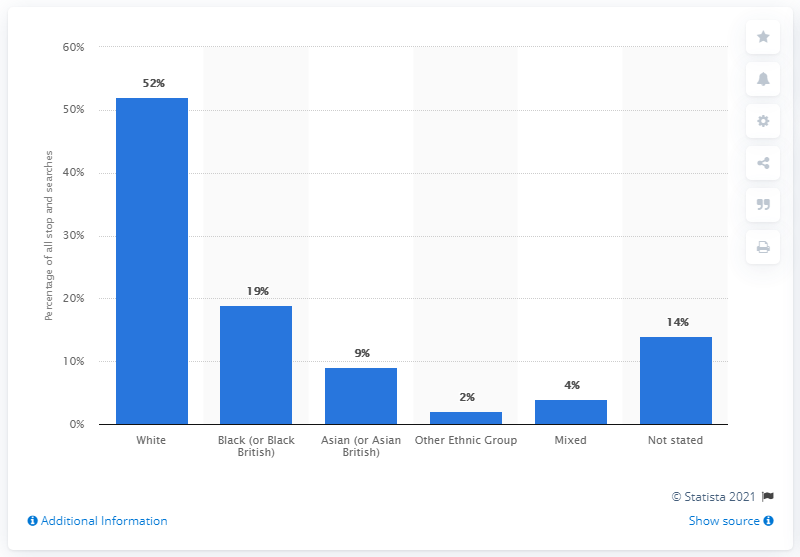Outline some significant characteristics in this image. In 19.%, of the searches conducted on individuals with a "black or black British" ethnicity, resulted in an arrest. 